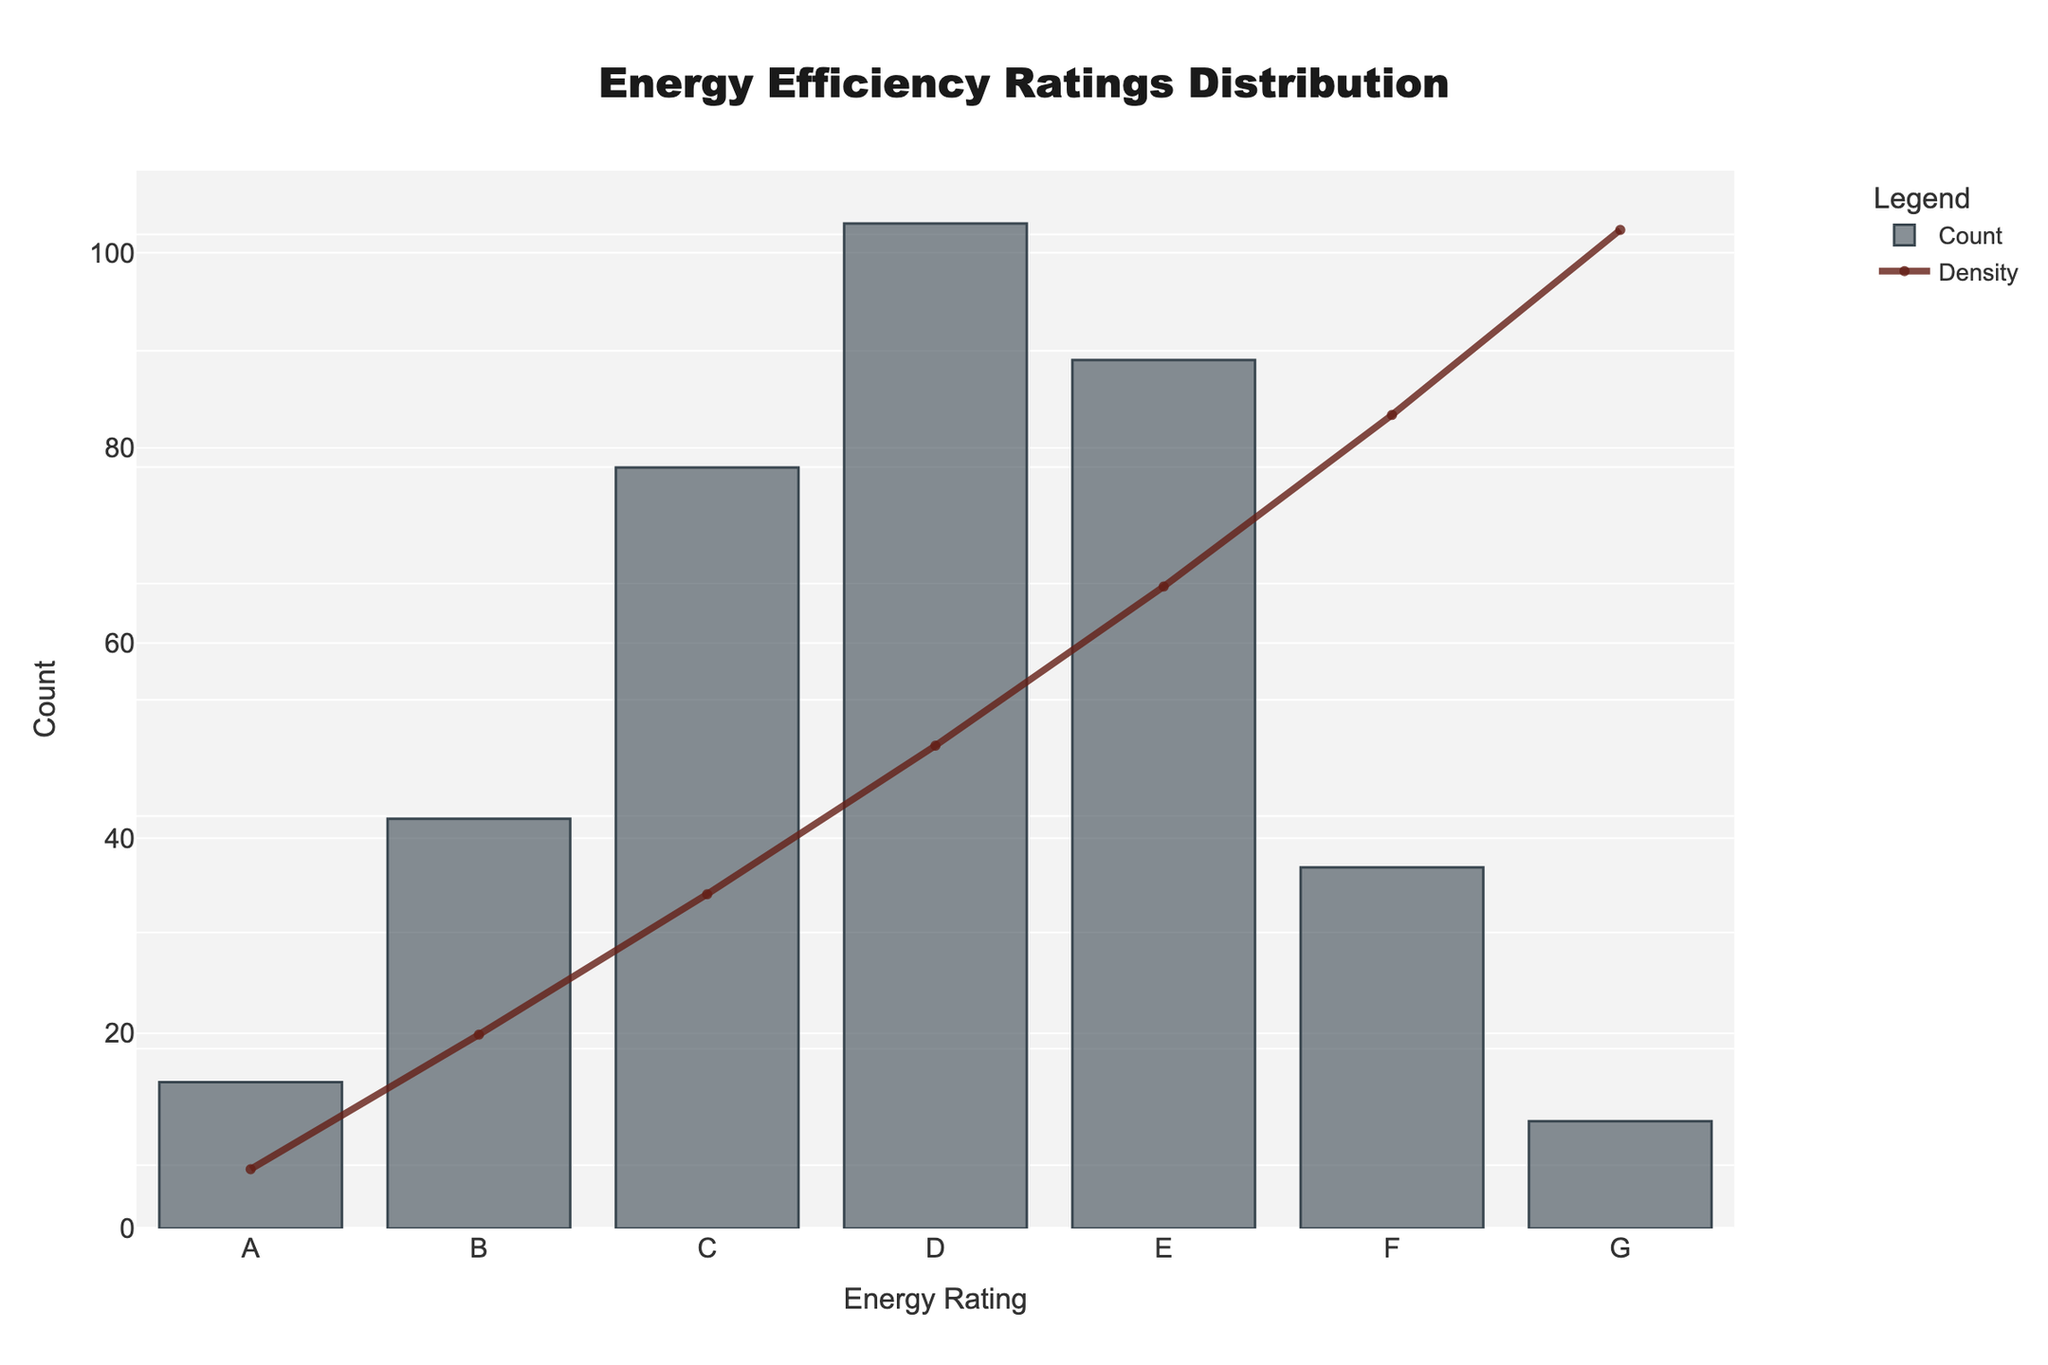What is the title of the figure? The title is displayed at the top and reads "Energy Efficiency Ratings Distribution".
Answer: Energy Efficiency Ratings Distribution What are the labels on the x-axis and y-axis? The x-axis label is "Energy Rating" and the y-axis label is "Count".
Answer: Energy Rating (x-axis), Count (y-axis) What colors are used for the bars and the KDE curve? The bars are colored in shades of dark grey and the KDE curve is in a dark reddish color.
Answer: Grey (bars), Reddish (KDE curve) What is the total number of newly constructed homes? Sum all the bar heights (counts) to find the total number: 15 + 42 + 78 + 103 + 89 + 37 + 11 = 375.
Answer: 375 What is the average count of homes per energy rating category? Divide the total number of homes by the number of categories: 375 homes / 7 categories = approximately 53.57 homes per category.
Answer: ~53.57 Which energy efficiency rating has the highest count? By examining the height of the bars, rating "D" has the highest count of 103.
Answer: D How does the count of homes with energy rating "A" compare to the count of homes with rating "G"? The bar for rating "A" is shorter than the bar for rating "G". Specifically, "A" has 15 homes, whereas "G" has 11 homes.
Answer: A > G Which energy efficiency rating category has the least number of homes? The shortest bar represents rating "G", which has 11 homes.
Answer: G What shape does the KDE curve take, and what can we infer from it? The KDE curve rises towards the middle and then falls, indicating the distribution of counts is higher around the middle energy ratings and lower at the extremes.
Answer: Bell-shaped distribution How do the peaks of the KDE curve relate to the energy ratings categories? The peak of the KDE curve aligns with the "D" rating category, suggesting it has the highest density of homes.
Answer: Peak at D 